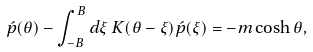Convert formula to latex. <formula><loc_0><loc_0><loc_500><loc_500>\acute { p } ( \theta ) - \int _ { - B } ^ { B } d \xi \, K ( \theta - \xi ) \acute { p } ( \xi ) = - m \cosh \theta ,</formula> 